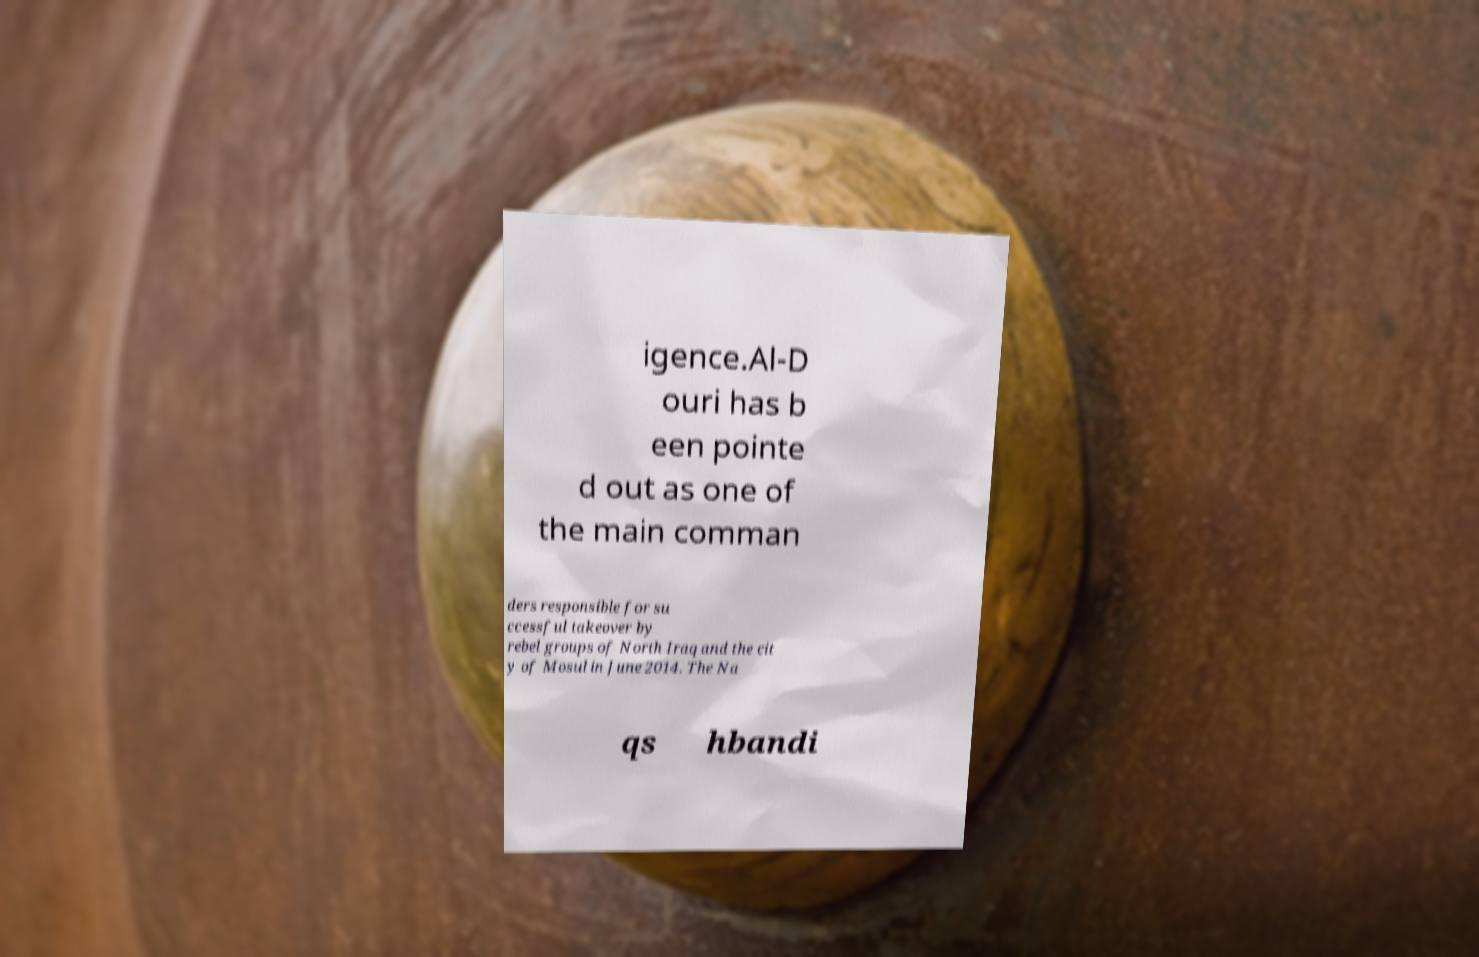Could you extract and type out the text from this image? igence.Al-D ouri has b een pointe d out as one of the main comman ders responsible for su ccessful takeover by rebel groups of North Iraq and the cit y of Mosul in June 2014. The Na qs hbandi 